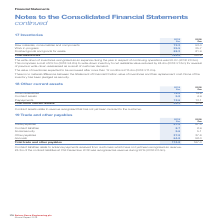According to Spirax Sarco Engineering Plc's financial document, What do contract liabilities relate to? advance payments received from customers which have not yet been recognised as revenue. The document states: "Contract liabilities relate to advance payments received from customers which have not yet been recognised as revenue. £8.3m of the contract liabiliti..." Also, How much of contract liabilities at 31st December 2018 was recognised as revenue during 2019? According to the financial document, £8.3m. The relevant text states: "ers which have not yet been recognised as revenue. £8.3m of the contract liabilities at 31st December 2018 was recognised as revenue during 2019 (2018: £3.0m..." Also, What are the components making up total trade and other payables? The document contains multiple relevant values: Trade payables, Contract liabilities, Social security, Other payables, Accruals. From the document: "tract liabilities 8.7 8.9 Social security 5.6 5.1 Other payables 37.8 37.6 Accruals 64.8 58.0 Total trade and other payables 174.8 167.0 e payables 57..." Additionally, In which year was the amount of trade payables larger? According to the financial document, 2019. The relevant text states: "Spirax-Sarco Engineering plc Annual Report 2019..." Also, can you calculate: What was the change in accruals in 2019 from 2018? Based on the calculation: 64.8-58.0, the result is 6.8 (in millions). This is based on the information: "ty 5.6 5.1 Other payables 37.8 37.6 Accruals 64.8 58.0 Total trade and other payables 174.8 167.0 ecurity 5.6 5.1 Other payables 37.8 37.6 Accruals 64.8 58.0 Total trade and other payables 174.8 167.0..." The key data points involved are: 58.0, 64.8. Also, can you calculate: What was the percentage change in accruals in 2019 from 2018? To answer this question, I need to perform calculations using the financial data. The calculation is: (64.8-58.0)/58.0, which equals 11.72 (percentage). This is based on the information: "ty 5.6 5.1 Other payables 37.8 37.6 Accruals 64.8 58.0 Total trade and other payables 174.8 167.0 ecurity 5.6 5.1 Other payables 37.8 37.6 Accruals 64.8 58.0 Total trade and other payables 174.8 167.0..." The key data points involved are: 58.0, 64.8. 